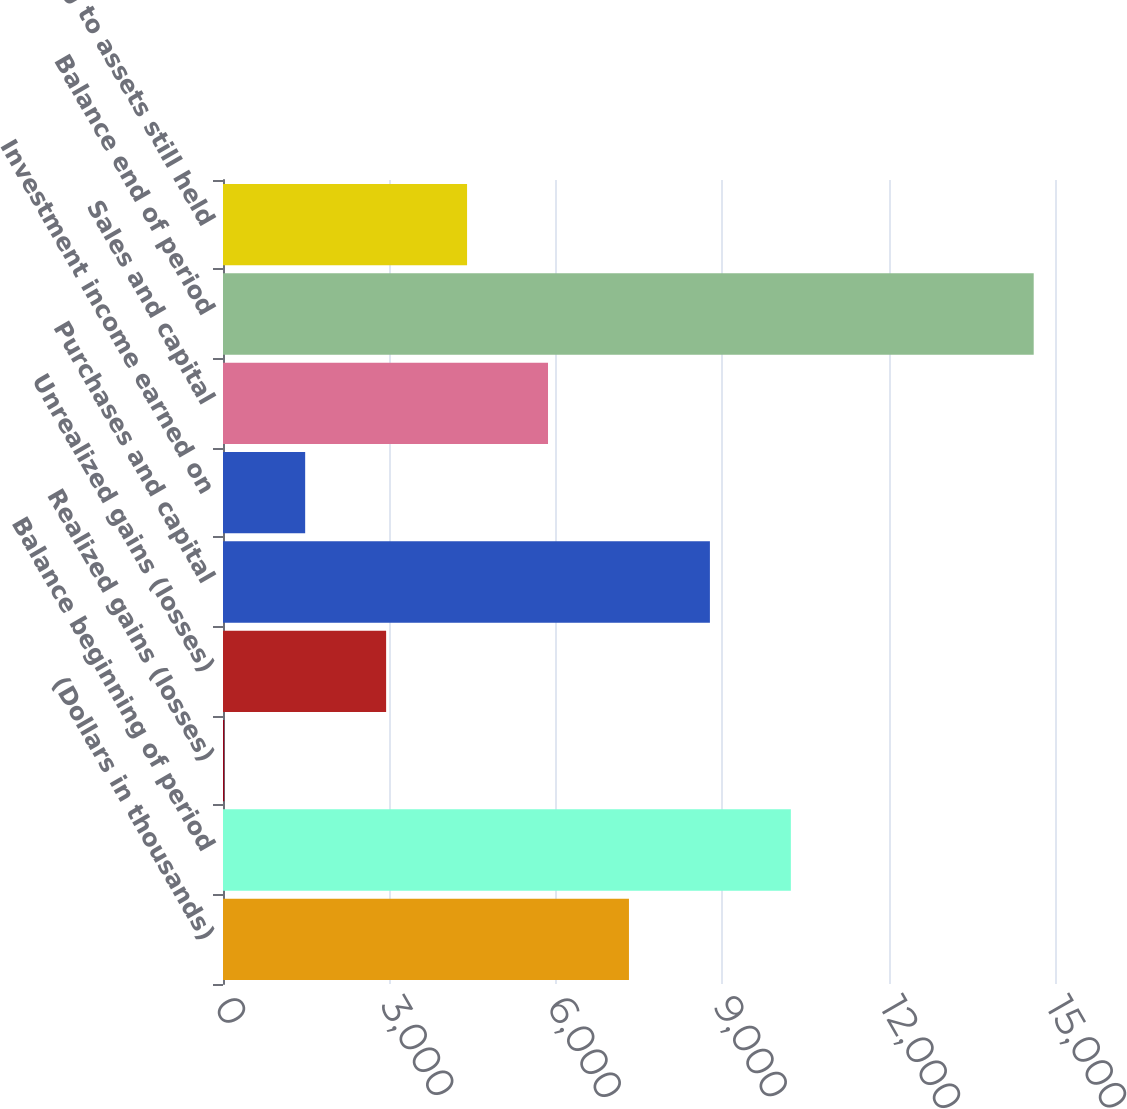Convert chart. <chart><loc_0><loc_0><loc_500><loc_500><bar_chart><fcel>(Dollars in thousands)<fcel>Balance beginning of period<fcel>Realized gains (losses)<fcel>Unrealized gains (losses)<fcel>Purchases and capital<fcel>Investment income earned on<fcel>Sales and capital<fcel>Balance end of period<fcel>relating to assets still held<nl><fcel>7319<fcel>10237.8<fcel>22<fcel>2940.8<fcel>8778.4<fcel>1481.4<fcel>5859.6<fcel>14616<fcel>4400.2<nl></chart> 